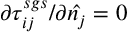Convert formula to latex. <formula><loc_0><loc_0><loc_500><loc_500>{ \partial \tau _ { i j } ^ { s g s } } / { \partial \hat { n _ { j } } } = 0</formula> 